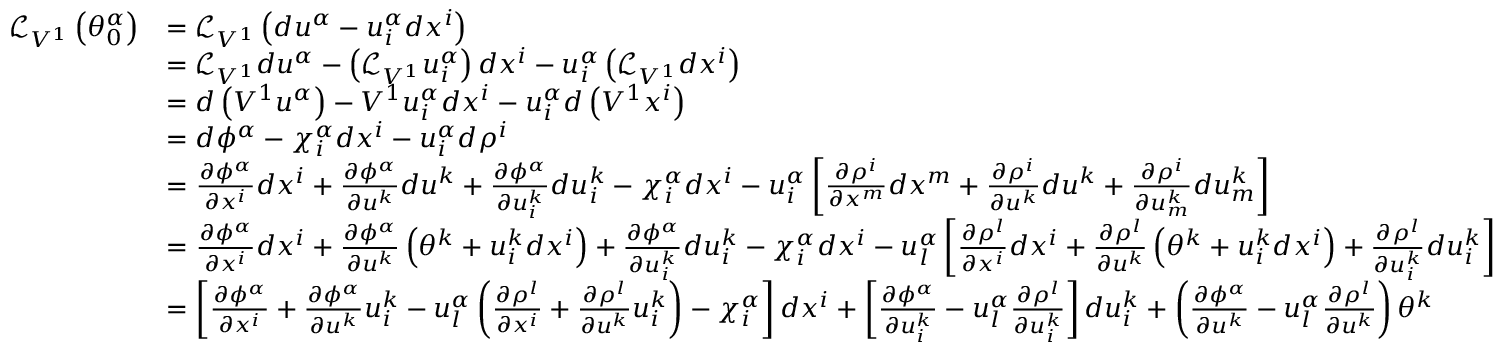<formula> <loc_0><loc_0><loc_500><loc_500>{ \begin{array} { r l } { { \mathcal { L } } _ { V ^ { 1 } } \left ( \theta _ { 0 } ^ { \alpha } \right ) } & { = { \mathcal { L } } _ { V ^ { 1 } } \left ( d u ^ { \alpha } - u _ { i } ^ { \alpha } d x ^ { i } \right ) } \\ & { = { \mathcal { L } } _ { V ^ { 1 } } d u ^ { \alpha } - \left ( { \mathcal { L } } _ { V ^ { 1 } } u _ { i } ^ { \alpha } \right ) d x ^ { i } - u _ { i } ^ { \alpha } \left ( { \mathcal { L } } _ { V ^ { 1 } } d x ^ { i } \right ) } \\ & { = d \left ( V ^ { 1 } u ^ { \alpha } \right ) - V ^ { 1 } u _ { i } ^ { \alpha } d x ^ { i } - u _ { i } ^ { \alpha } d \left ( V ^ { 1 } x ^ { i } \right ) } \\ & { = d \phi ^ { \alpha } - \chi _ { i } ^ { \alpha } d x ^ { i } - u _ { i } ^ { \alpha } d \rho ^ { i } } \\ & { = { \frac { \partial \phi ^ { \alpha } } { \partial x ^ { i } } } d x ^ { i } + { \frac { \partial \phi ^ { \alpha } } { \partial u ^ { k } } } d u ^ { k } + { \frac { \partial \phi ^ { \alpha } } { \partial u _ { i } ^ { k } } } d u _ { i } ^ { k } - \chi _ { i } ^ { \alpha } d x ^ { i } - u _ { i } ^ { \alpha } \left [ { \frac { \partial \rho ^ { i } } { \partial x ^ { m } } } d x ^ { m } + { \frac { \partial \rho ^ { i } } { \partial u ^ { k } } } d u ^ { k } + { \frac { \partial \rho ^ { i } } { \partial u _ { m } ^ { k } } } d u _ { m } ^ { k } \right ] } \\ & { = { \frac { \partial \phi ^ { \alpha } } { \partial x ^ { i } } } d x ^ { i } + { \frac { \partial \phi ^ { \alpha } } { \partial u ^ { k } } } \left ( \theta ^ { k } + u _ { i } ^ { k } d x ^ { i } \right ) + { \frac { \partial \phi ^ { \alpha } } { \partial u _ { i } ^ { k } } } d u _ { i } ^ { k } - \chi _ { i } ^ { \alpha } d x ^ { i } - u _ { l } ^ { \alpha } \left [ { \frac { \partial \rho ^ { l } } { \partial x ^ { i } } } d x ^ { i } + { \frac { \partial \rho ^ { l } } { \partial u ^ { k } } } \left ( \theta ^ { k } + u _ { i } ^ { k } d x ^ { i } \right ) + { \frac { \partial \rho ^ { l } } { \partial u _ { i } ^ { k } } } d u _ { i } ^ { k } \right ] } \\ & { = \left [ { \frac { \partial \phi ^ { \alpha } } { \partial x ^ { i } } } + { \frac { \partial \phi ^ { \alpha } } { \partial u ^ { k } } } u _ { i } ^ { k } - u _ { l } ^ { \alpha } \left ( { \frac { \partial \rho ^ { l } } { \partial x ^ { i } } } + { \frac { \partial \rho ^ { l } } { \partial u ^ { k } } } u _ { i } ^ { k } \right ) - \chi _ { i } ^ { \alpha } \right ] d x ^ { i } + \left [ { \frac { \partial \phi ^ { \alpha } } { \partial u _ { i } ^ { k } } } - u _ { l } ^ { \alpha } { \frac { \partial \rho ^ { l } } { \partial u _ { i } ^ { k } } } \right ] d u _ { i } ^ { k } + \left ( { \frac { \partial \phi ^ { \alpha } } { \partial u ^ { k } } } - u _ { l } ^ { \alpha } { \frac { \partial \rho ^ { l } } { \partial u ^ { k } } } \right ) \theta ^ { k } } \end{array} }</formula> 